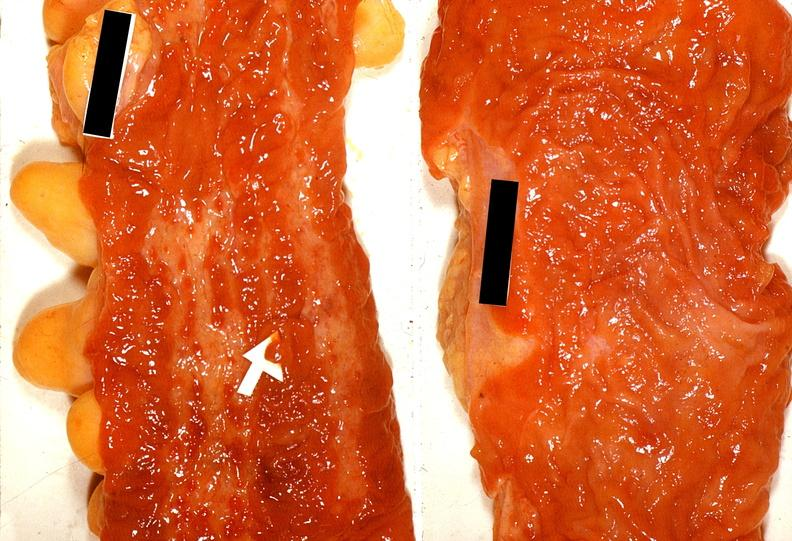what is present?
Answer the question using a single word or phrase. Gastrointestinal 